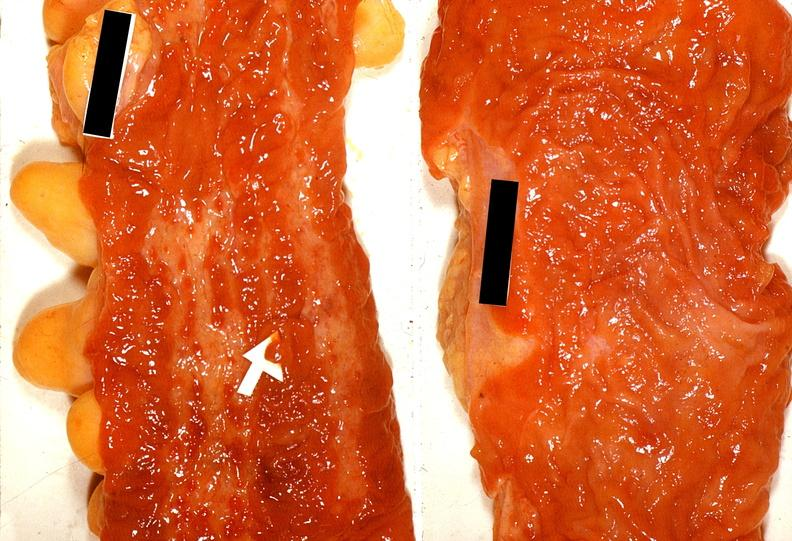what is present?
Answer the question using a single word or phrase. Gastrointestinal 